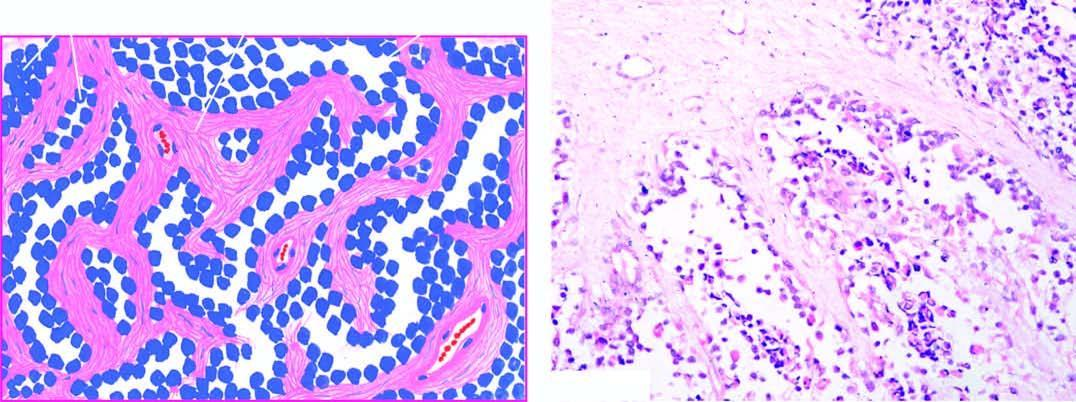s the tumour divided into alveolar spaces composed of fibrocollagenous tissue?
Answer the question using a single word or phrase. Yes 